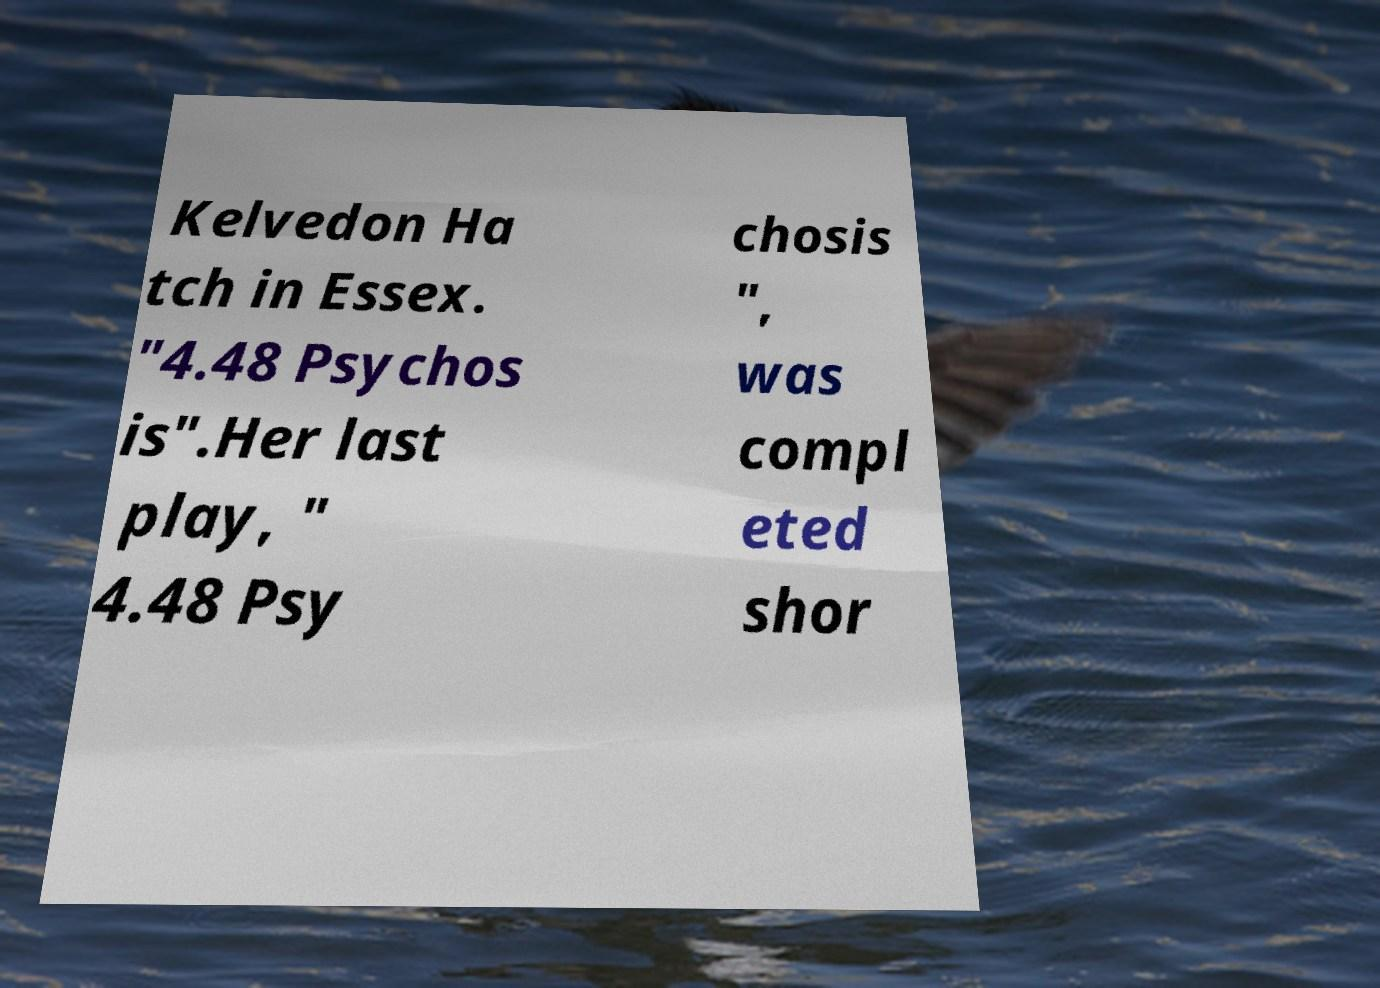Please identify and transcribe the text found in this image. Kelvedon Ha tch in Essex. "4.48 Psychos is".Her last play, " 4.48 Psy chosis ", was compl eted shor 